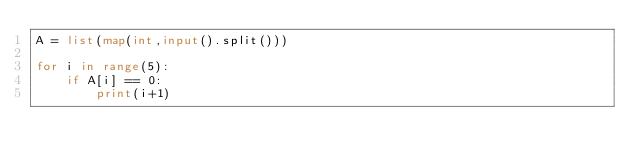<code> <loc_0><loc_0><loc_500><loc_500><_Python_>A = list(map(int,input().split()))

for i in range(5):
    if A[i] == 0:
        print(i+1)
</code> 